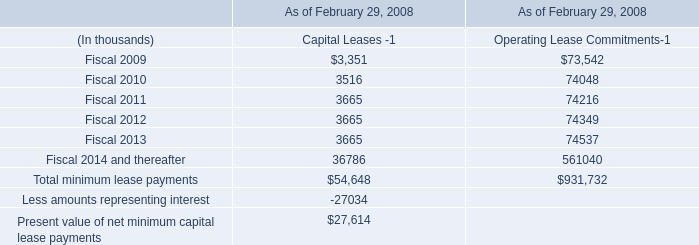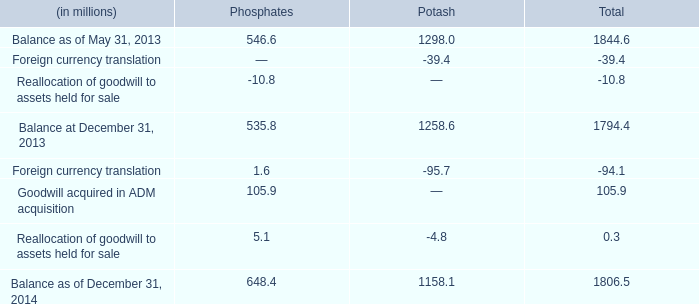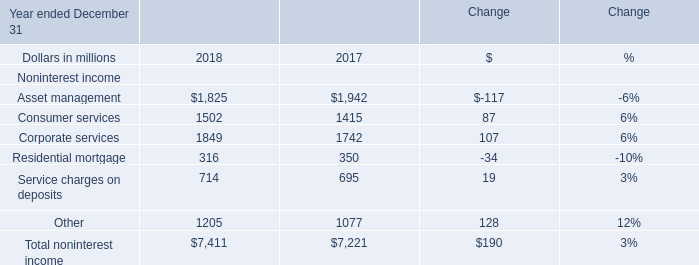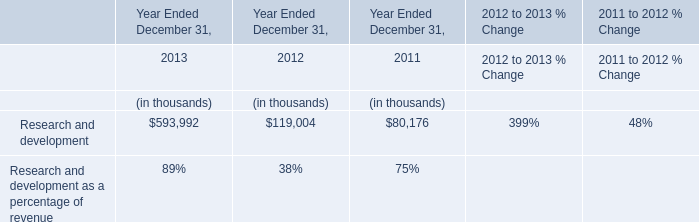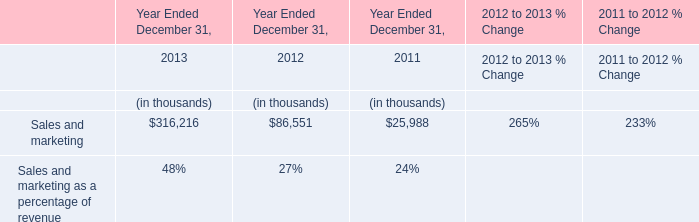What's the average of the Research and development in the years where Sales and marketing is positive? (in thousand) 
Computations: (((593992 + 119004) + 80176) / 3)
Answer: 264390.66667. 